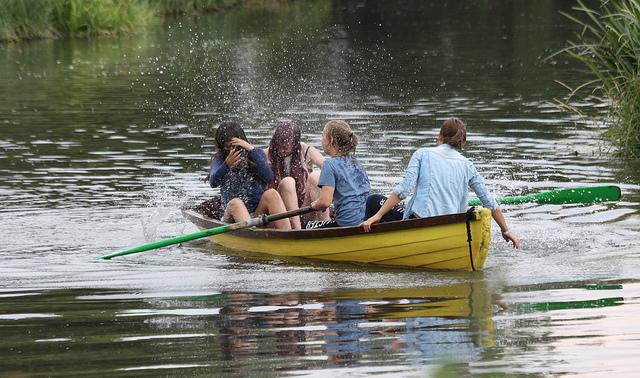What is the green item? oar 